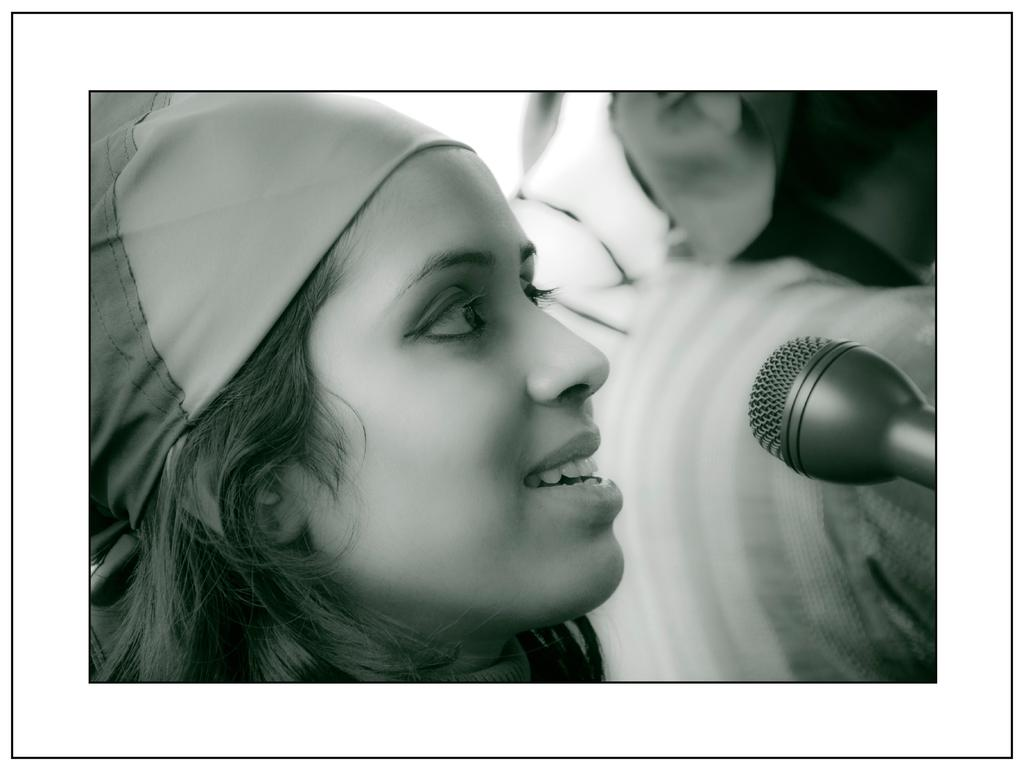What is the color scheme of the image? The image is black and white. Can you describe the main subject in the image? There is a person in the image. What is the person doing in the image? The person is in front of a microphone. What type of dinner is being served in the image? There is no dinner present in the image; it is a black and white image of a person in front of a microphone. How does the person's temper affect the microphone in the image? The person's temper is not mentioned or depicted in the image, and therefore it cannot be determined how it might affect the microphone. 